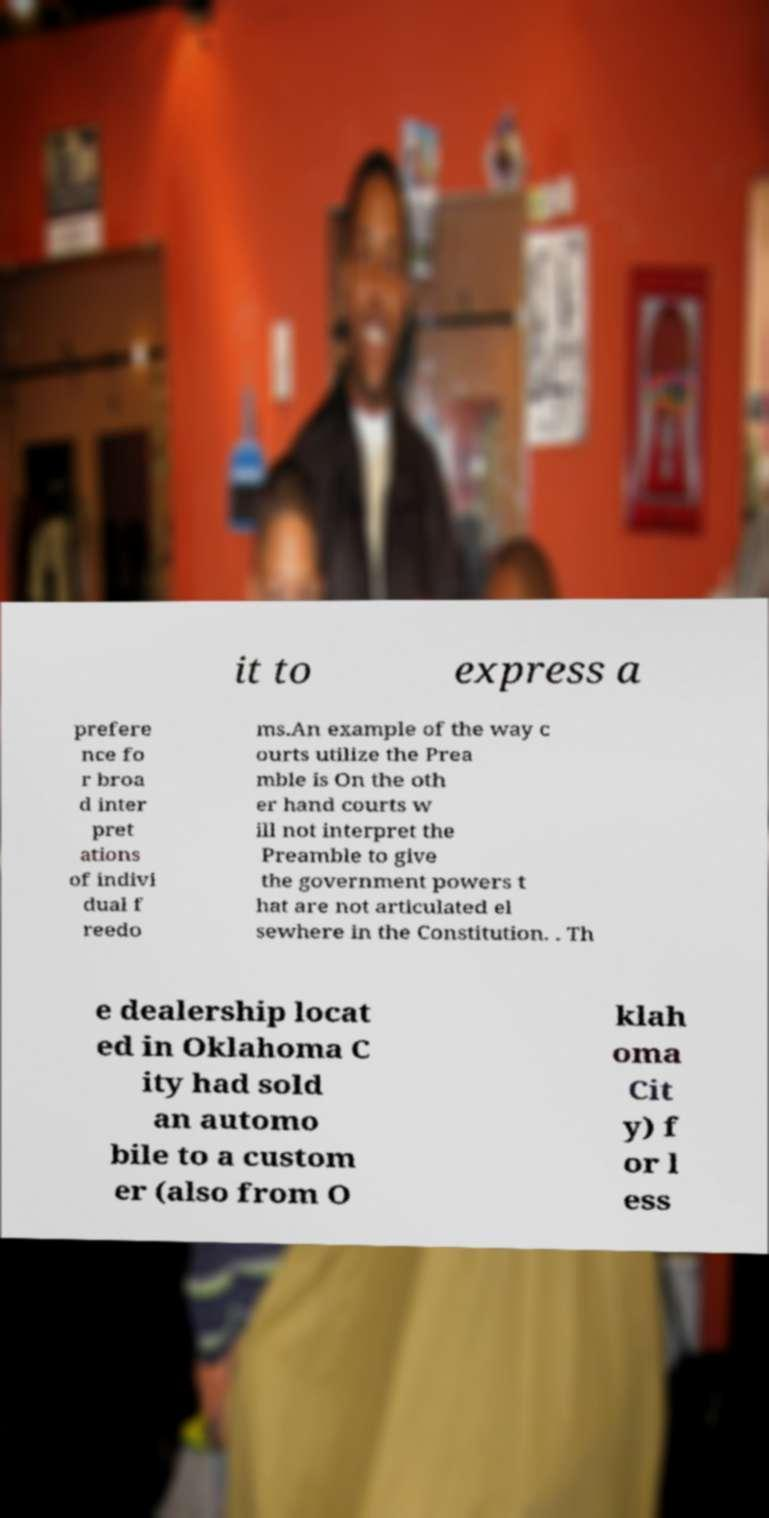Can you accurately transcribe the text from the provided image for me? it to express a prefere nce fo r broa d inter pret ations of indivi dual f reedo ms.An example of the way c ourts utilize the Prea mble is On the oth er hand courts w ill not interpret the Preamble to give the government powers t hat are not articulated el sewhere in the Constitution. . Th e dealership locat ed in Oklahoma C ity had sold an automo bile to a custom er (also from O klah oma Cit y) f or l ess 